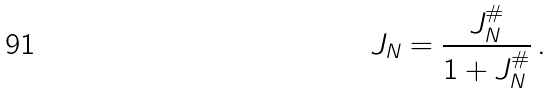Convert formula to latex. <formula><loc_0><loc_0><loc_500><loc_500>J _ { N } = \frac { J _ { N } ^ { \# } } { 1 + J _ { N } ^ { \# } } \, .</formula> 